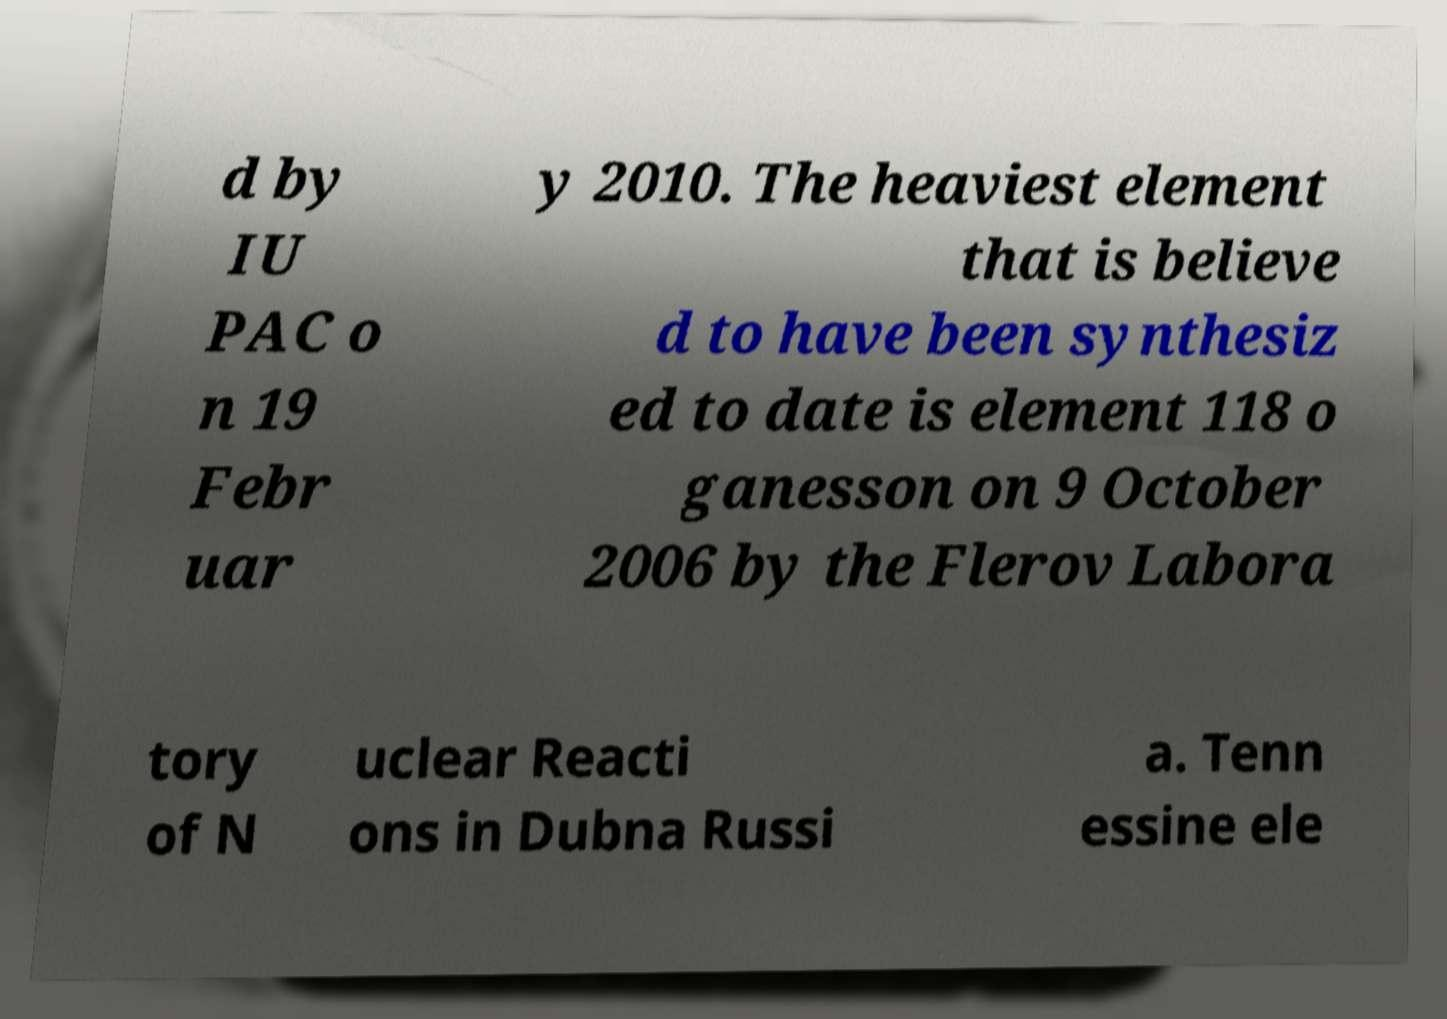Can you read and provide the text displayed in the image?This photo seems to have some interesting text. Can you extract and type it out for me? d by IU PAC o n 19 Febr uar y 2010. The heaviest element that is believe d to have been synthesiz ed to date is element 118 o ganesson on 9 October 2006 by the Flerov Labora tory of N uclear Reacti ons in Dubna Russi a. Tenn essine ele 